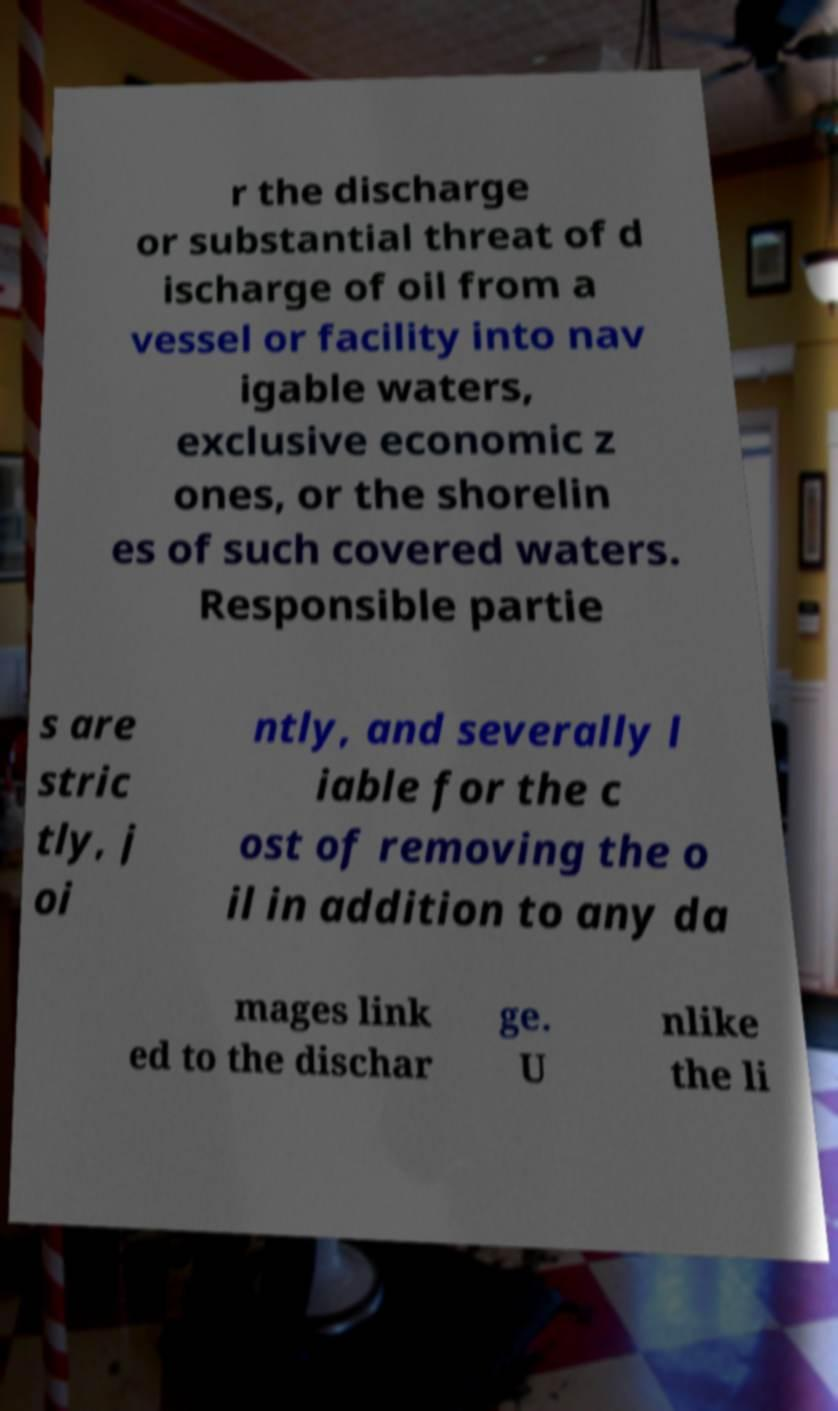Can you read and provide the text displayed in the image?This photo seems to have some interesting text. Can you extract and type it out for me? r the discharge or substantial threat of d ischarge of oil from a vessel or facility into nav igable waters, exclusive economic z ones, or the shorelin es of such covered waters. Responsible partie s are stric tly, j oi ntly, and severally l iable for the c ost of removing the o il in addition to any da mages link ed to the dischar ge. U nlike the li 